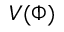<formula> <loc_0><loc_0><loc_500><loc_500>V ( \Phi )</formula> 